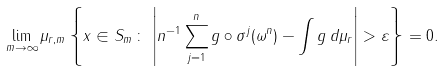<formula> <loc_0><loc_0><loc_500><loc_500>\lim _ { m \rightarrow \infty } \mu _ { r , m } \left \{ x \in S _ { m } \, \colon \, \left | n ^ { - 1 } \sum _ { j = 1 } ^ { n } g \circ \sigma ^ { j } ( \omega ^ { n } ) - \int g \, d \mu _ { r } \right | > \varepsilon \right \} = 0 .</formula> 